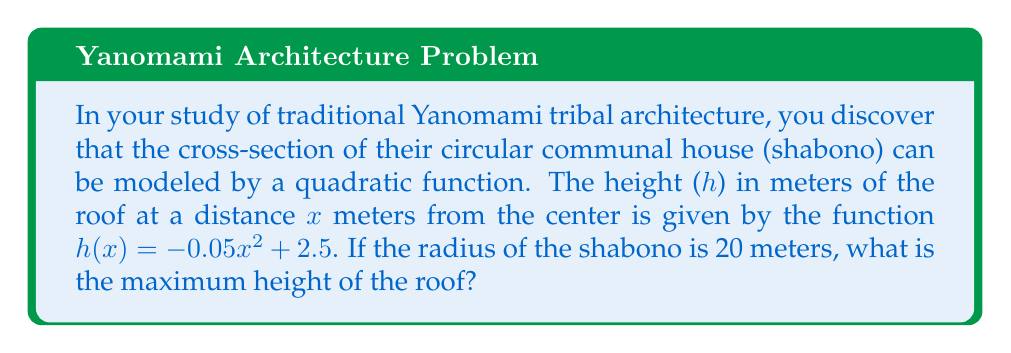Can you answer this question? To find the maximum height of the roof, we need to follow these steps:

1) The quadratic function is in the form $h(x) = -ax^2 + b$, where $a = 0.05$ and $b = 2.5$.

2) For a quadratic function in this form, the vertex represents the maximum point, and it occurs at $x = 0$.

3) To find the maximum height, we simply need to evaluate $h(0)$:

   $h(0) = -0.05(0)^2 + 2.5$
   $h(0) = 0 + 2.5$
   $h(0) = 2.5$

4) Therefore, the maximum height of the roof is 2.5 meters, which occurs at the center of the shabono.

Note: The radius of 20 meters given in the question is not needed to solve this particular problem, but it provides context for the architectural structure being studied.
Answer: 2.5 meters 